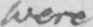Please transcribe the handwritten text in this image. were 